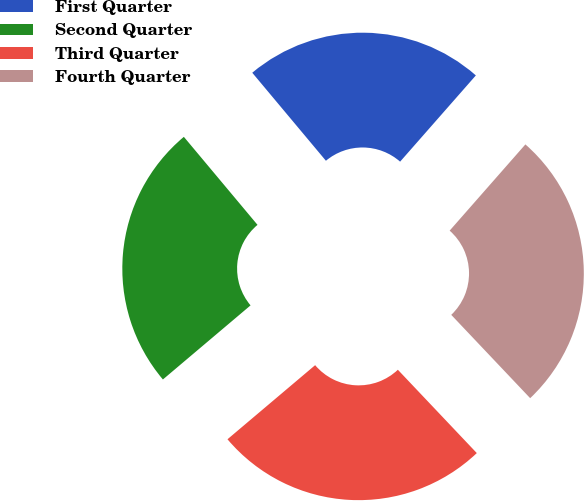Convert chart to OTSL. <chart><loc_0><loc_0><loc_500><loc_500><pie_chart><fcel>First Quarter<fcel>Second Quarter<fcel>Third Quarter<fcel>Fourth Quarter<nl><fcel>22.56%<fcel>25.08%<fcel>25.9%<fcel>26.46%<nl></chart> 